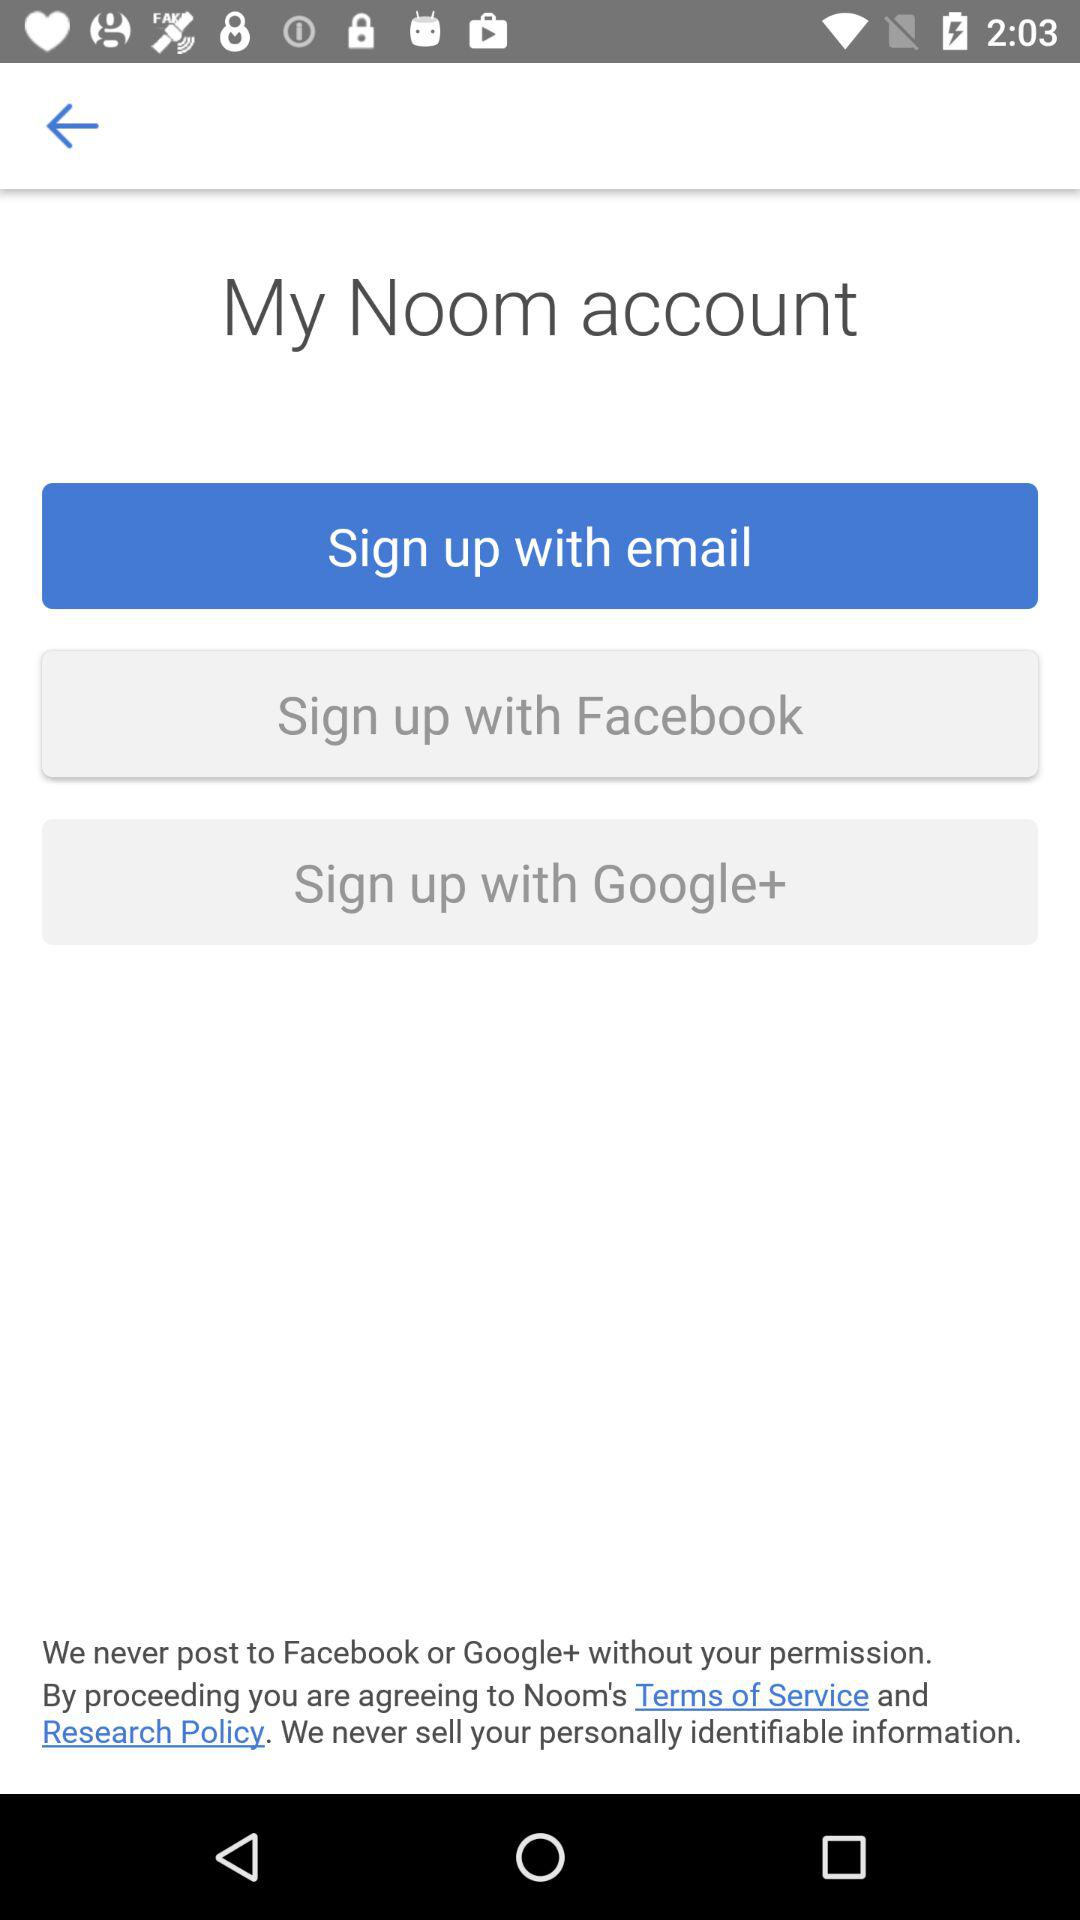How many policies are mentioned?
Answer the question using a single word or phrase. 2 